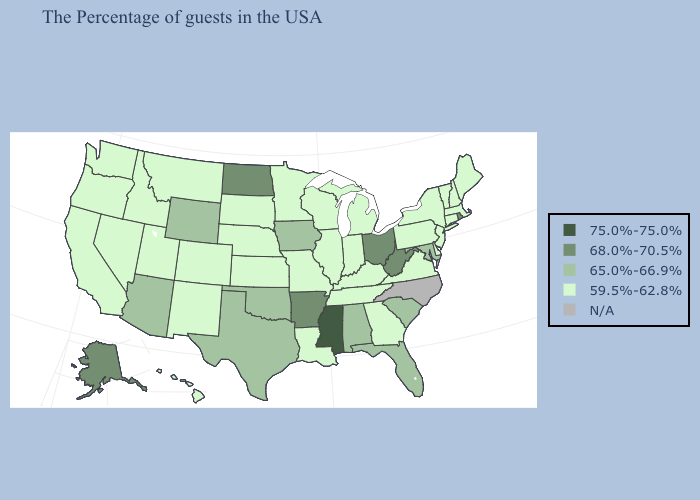What is the value of Texas?
Keep it brief. 65.0%-66.9%. Which states have the highest value in the USA?
Quick response, please. Mississippi. Does Florida have the lowest value in the USA?
Short answer required. No. What is the lowest value in the Northeast?
Be succinct. 59.5%-62.8%. Name the states that have a value in the range 65.0%-66.9%?
Give a very brief answer. Maryland, South Carolina, Florida, Alabama, Iowa, Oklahoma, Texas, Wyoming, Arizona. Does Georgia have the highest value in the USA?
Write a very short answer. No. What is the value of Utah?
Short answer required. 59.5%-62.8%. Name the states that have a value in the range 75.0%-75.0%?
Quick response, please. Mississippi. How many symbols are there in the legend?
Be succinct. 5. What is the highest value in the USA?
Give a very brief answer. 75.0%-75.0%. Name the states that have a value in the range 75.0%-75.0%?
Keep it brief. Mississippi. What is the value of Massachusetts?
Short answer required. 59.5%-62.8%. Name the states that have a value in the range 59.5%-62.8%?
Quick response, please. Maine, Massachusetts, New Hampshire, Vermont, Connecticut, New York, New Jersey, Delaware, Pennsylvania, Virginia, Georgia, Michigan, Kentucky, Indiana, Tennessee, Wisconsin, Illinois, Louisiana, Missouri, Minnesota, Kansas, Nebraska, South Dakota, Colorado, New Mexico, Utah, Montana, Idaho, Nevada, California, Washington, Oregon, Hawaii. Among the states that border Connecticut , does Rhode Island have the highest value?
Write a very short answer. Yes. 